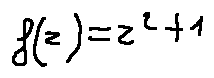<formula> <loc_0><loc_0><loc_500><loc_500>f ( z ) = z ^ { 2 } + 1</formula> 